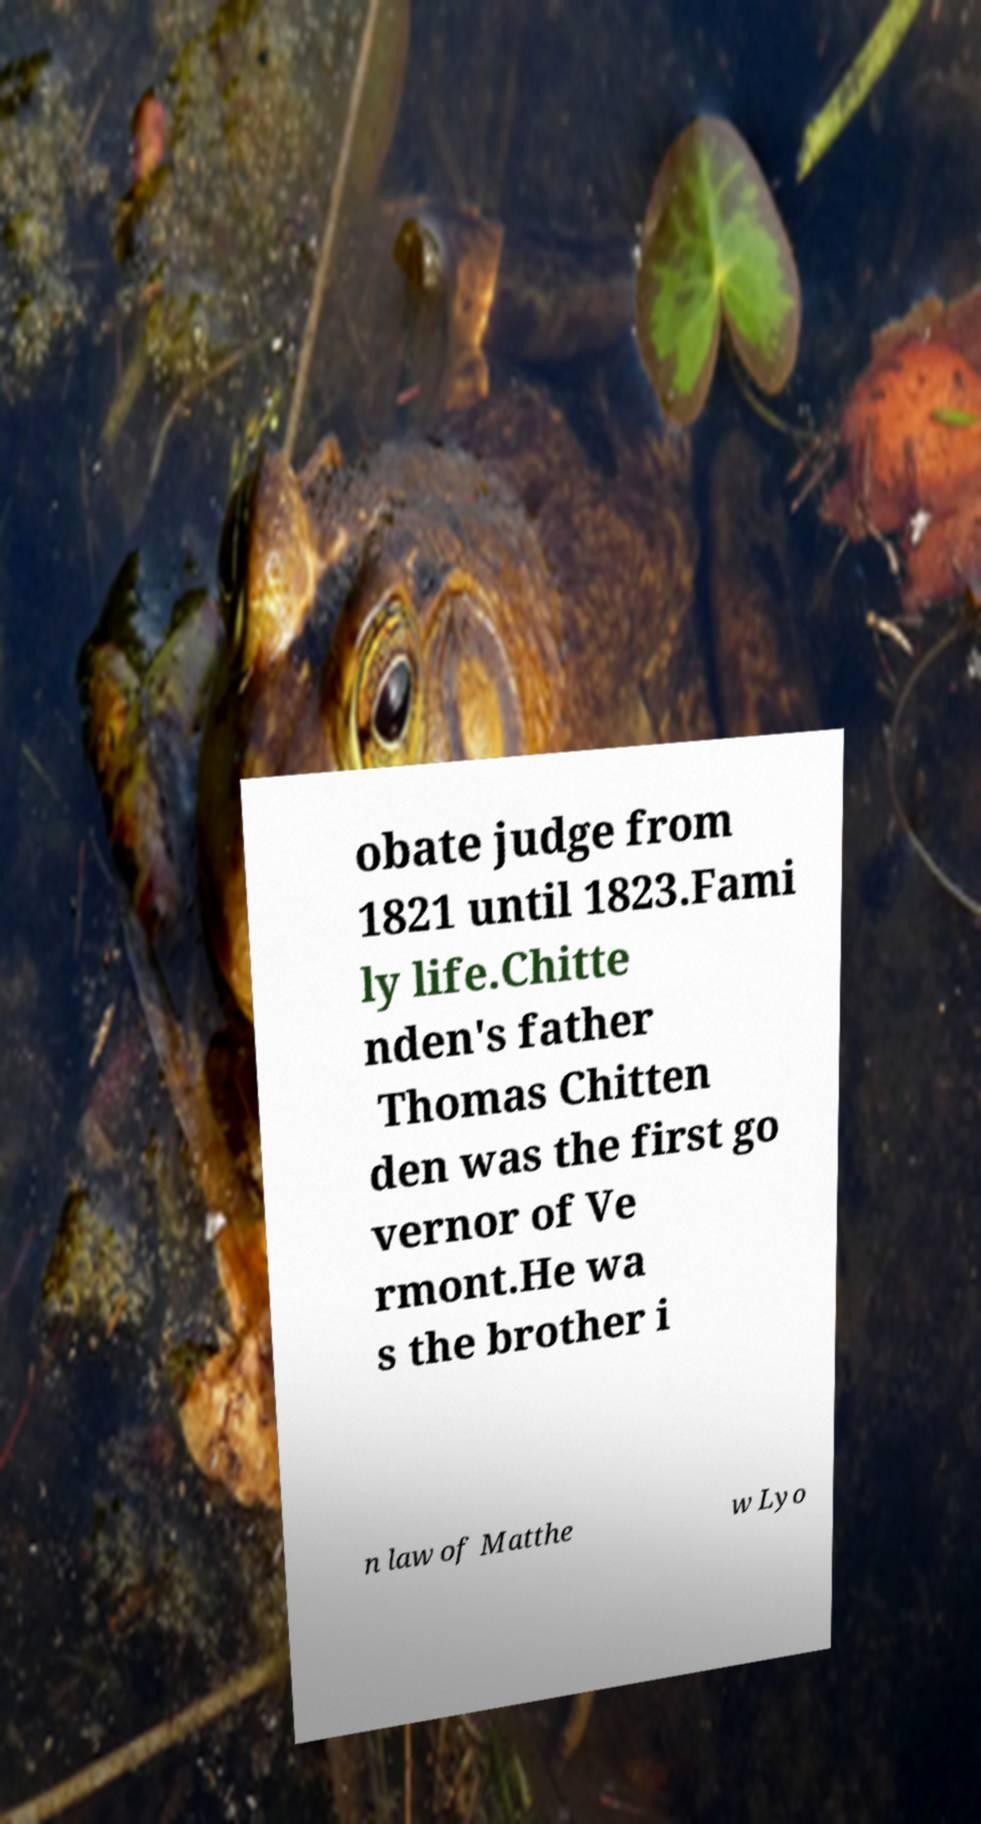Could you assist in decoding the text presented in this image and type it out clearly? obate judge from 1821 until 1823.Fami ly life.Chitte nden's father Thomas Chitten den was the first go vernor of Ve rmont.He wa s the brother i n law of Matthe w Lyo 